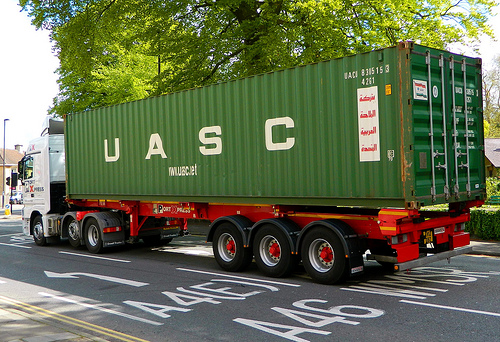On which side of the picture is the lamp? The lamp is on the left side of the picture. 